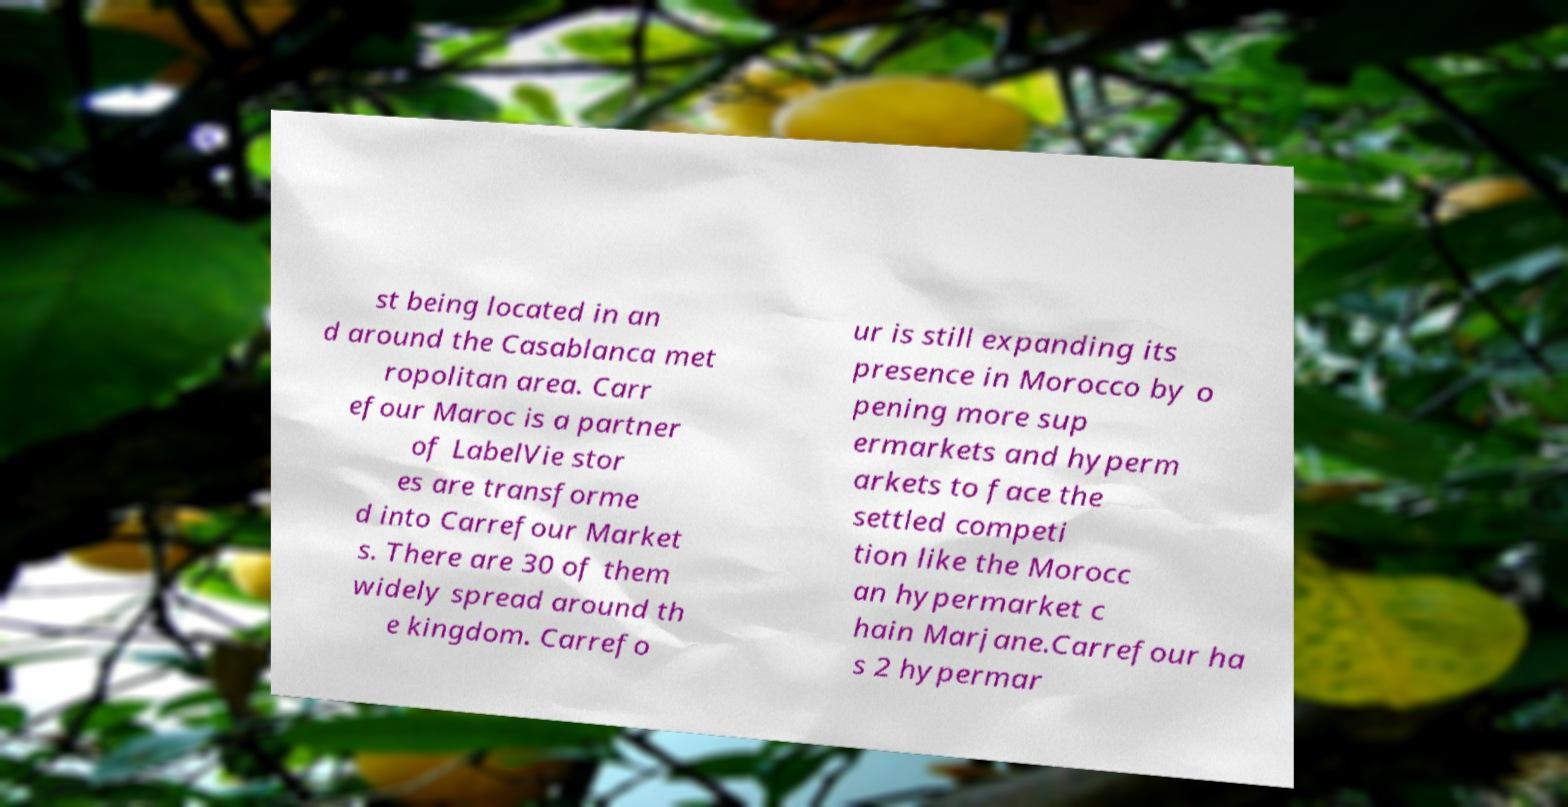There's text embedded in this image that I need extracted. Can you transcribe it verbatim? st being located in an d around the Casablanca met ropolitan area. Carr efour Maroc is a partner of LabelVie stor es are transforme d into Carrefour Market s. There are 30 of them widely spread around th e kingdom. Carrefo ur is still expanding its presence in Morocco by o pening more sup ermarkets and hyperm arkets to face the settled competi tion like the Morocc an hypermarket c hain Marjane.Carrefour ha s 2 hypermar 